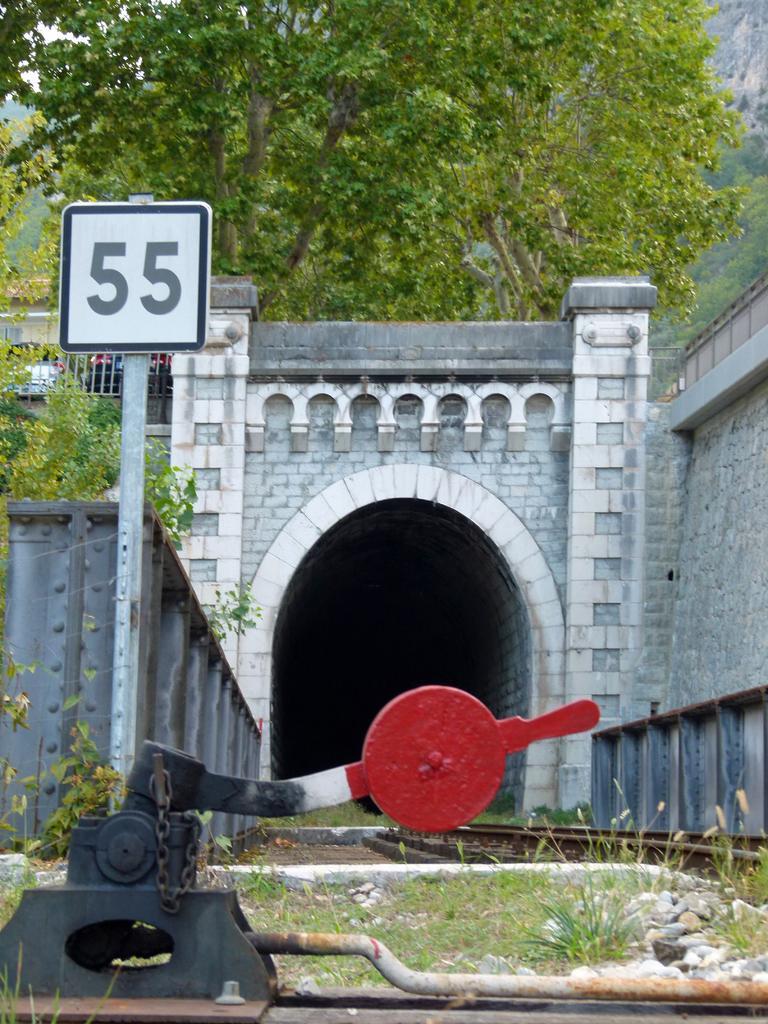Could you give a brief overview of what you see in this image? This image is taken outdoors. At the bottom of the image there is a check post and there is a ground with grass and pebbles on it. At the top of the image there is a tree. On the left side of the image there is a board. In the middle of the image there is a tunnel with walls. 